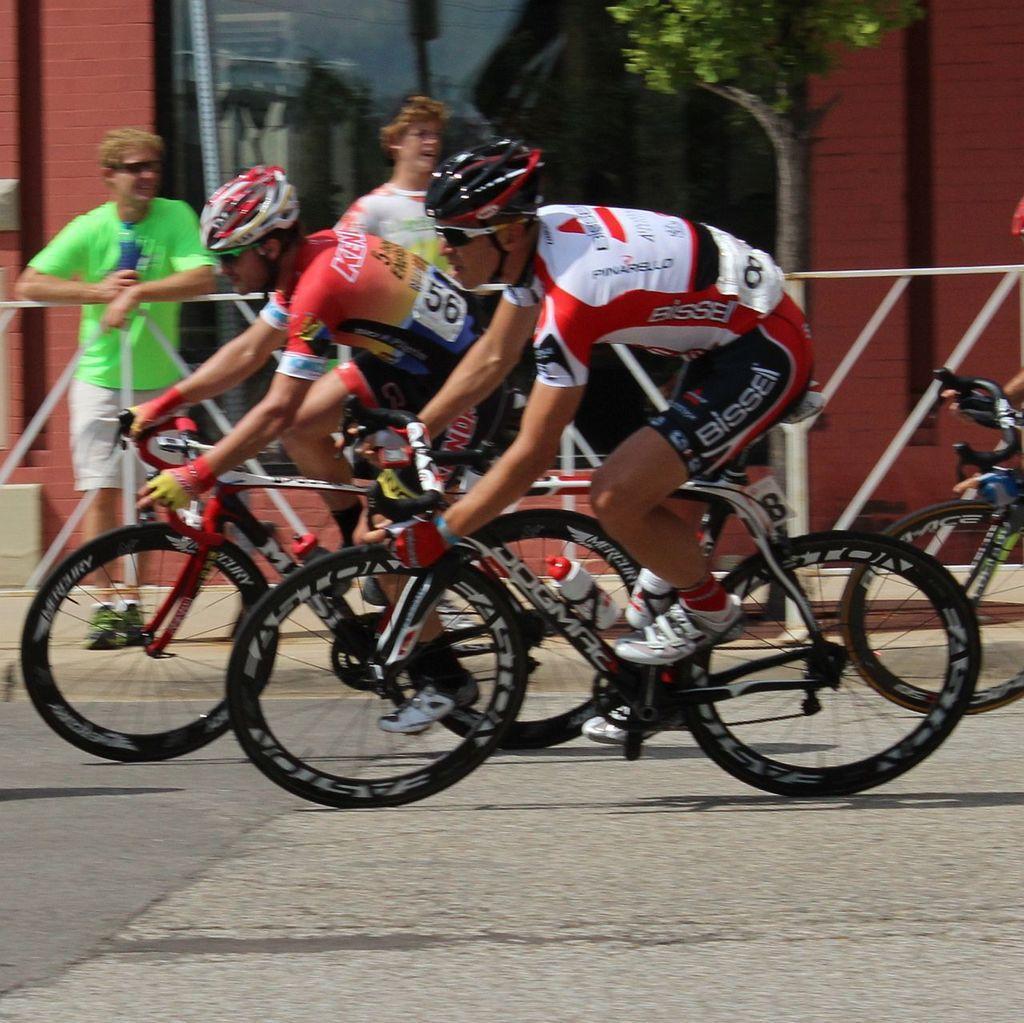How would you summarize this image in a sentence or two? In this picture there are two people who are wearing the helmets and riding the bicycles and beside them there are two people standing on the foot path and a tree. 